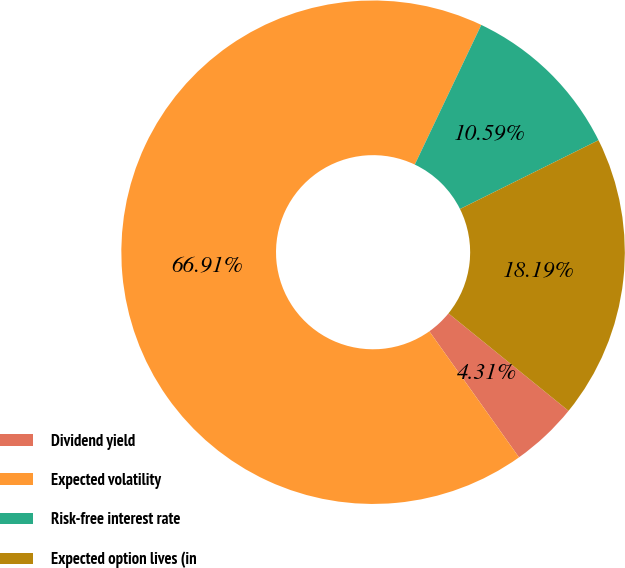<chart> <loc_0><loc_0><loc_500><loc_500><pie_chart><fcel>Dividend yield<fcel>Expected volatility<fcel>Risk-free interest rate<fcel>Expected option lives (in<nl><fcel>4.31%<fcel>66.92%<fcel>10.59%<fcel>18.19%<nl></chart> 